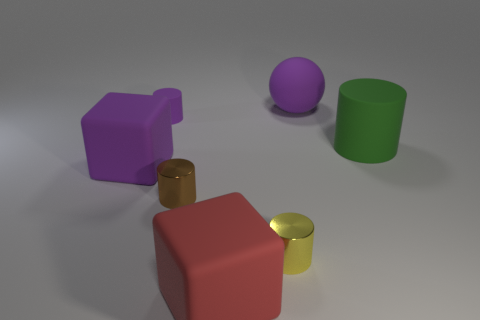Subtract all brown metallic cylinders. How many cylinders are left? 3 Add 1 matte cylinders. How many objects exist? 8 Subtract all red cubes. How many cubes are left? 1 Subtract 1 cylinders. How many cylinders are left? 3 Subtract all spheres. How many objects are left? 6 Add 6 big spheres. How many big spheres are left? 7 Add 5 blue metal cubes. How many blue metal cubes exist? 5 Subtract 0 brown balls. How many objects are left? 7 Subtract all yellow spheres. Subtract all purple cubes. How many spheres are left? 1 Subtract all small gray matte objects. Subtract all big purple rubber spheres. How many objects are left? 6 